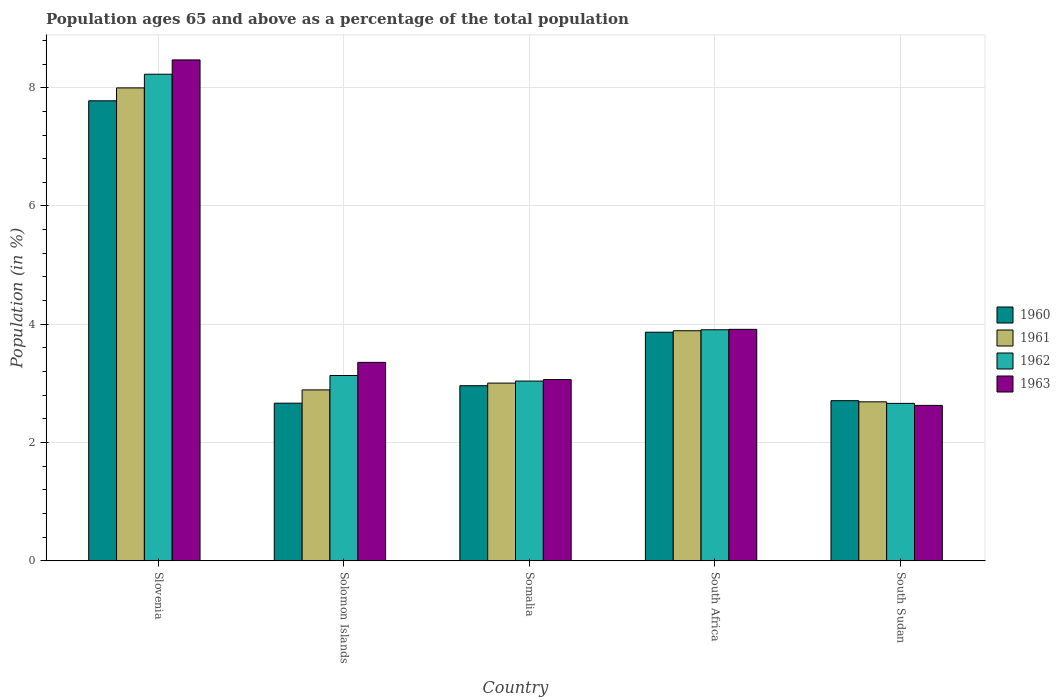How many different coloured bars are there?
Ensure brevity in your answer.  4. Are the number of bars per tick equal to the number of legend labels?
Ensure brevity in your answer.  Yes. What is the label of the 1st group of bars from the left?
Your answer should be compact. Slovenia. In how many cases, is the number of bars for a given country not equal to the number of legend labels?
Keep it short and to the point. 0. What is the percentage of the population ages 65 and above in 1961 in South Sudan?
Make the answer very short. 2.69. Across all countries, what is the maximum percentage of the population ages 65 and above in 1962?
Your answer should be very brief. 8.23. Across all countries, what is the minimum percentage of the population ages 65 and above in 1963?
Offer a terse response. 2.63. In which country was the percentage of the population ages 65 and above in 1961 maximum?
Make the answer very short. Slovenia. In which country was the percentage of the population ages 65 and above in 1962 minimum?
Keep it short and to the point. South Sudan. What is the total percentage of the population ages 65 and above in 1961 in the graph?
Your answer should be compact. 20.47. What is the difference between the percentage of the population ages 65 and above in 1962 in South Africa and that in South Sudan?
Offer a very short reply. 1.24. What is the difference between the percentage of the population ages 65 and above in 1960 in South Africa and the percentage of the population ages 65 and above in 1963 in Solomon Islands?
Keep it short and to the point. 0.51. What is the average percentage of the population ages 65 and above in 1962 per country?
Provide a succinct answer. 4.19. What is the difference between the percentage of the population ages 65 and above of/in 1960 and percentage of the population ages 65 and above of/in 1962 in South Sudan?
Your response must be concise. 0.05. What is the ratio of the percentage of the population ages 65 and above in 1960 in Slovenia to that in South Africa?
Provide a short and direct response. 2.01. What is the difference between the highest and the second highest percentage of the population ages 65 and above in 1962?
Your answer should be compact. 4.32. What is the difference between the highest and the lowest percentage of the population ages 65 and above in 1961?
Offer a very short reply. 5.31. In how many countries, is the percentage of the population ages 65 and above in 1963 greater than the average percentage of the population ages 65 and above in 1963 taken over all countries?
Your answer should be compact. 1. Is the sum of the percentage of the population ages 65 and above in 1962 in Solomon Islands and South Africa greater than the maximum percentage of the population ages 65 and above in 1963 across all countries?
Provide a succinct answer. No. Is it the case that in every country, the sum of the percentage of the population ages 65 and above in 1963 and percentage of the population ages 65 and above in 1960 is greater than the sum of percentage of the population ages 65 and above in 1961 and percentage of the population ages 65 and above in 1962?
Your response must be concise. No. What does the 2nd bar from the right in Slovenia represents?
Provide a succinct answer. 1962. Is it the case that in every country, the sum of the percentage of the population ages 65 and above in 1961 and percentage of the population ages 65 and above in 1962 is greater than the percentage of the population ages 65 and above in 1960?
Make the answer very short. Yes. How many bars are there?
Provide a short and direct response. 20. What is the difference between two consecutive major ticks on the Y-axis?
Ensure brevity in your answer.  2. Does the graph contain any zero values?
Make the answer very short. No. Does the graph contain grids?
Your answer should be compact. Yes. Where does the legend appear in the graph?
Ensure brevity in your answer.  Center right. How many legend labels are there?
Provide a succinct answer. 4. How are the legend labels stacked?
Offer a terse response. Vertical. What is the title of the graph?
Offer a terse response. Population ages 65 and above as a percentage of the total population. What is the label or title of the X-axis?
Give a very brief answer. Country. What is the label or title of the Y-axis?
Your answer should be very brief. Population (in %). What is the Population (in %) in 1960 in Slovenia?
Give a very brief answer. 7.78. What is the Population (in %) of 1961 in Slovenia?
Make the answer very short. 8. What is the Population (in %) of 1962 in Slovenia?
Your answer should be compact. 8.23. What is the Population (in %) in 1963 in Slovenia?
Offer a terse response. 8.47. What is the Population (in %) of 1960 in Solomon Islands?
Your answer should be very brief. 2.67. What is the Population (in %) in 1961 in Solomon Islands?
Provide a succinct answer. 2.89. What is the Population (in %) of 1962 in Solomon Islands?
Offer a very short reply. 3.13. What is the Population (in %) of 1963 in Solomon Islands?
Provide a short and direct response. 3.36. What is the Population (in %) of 1960 in Somalia?
Give a very brief answer. 2.96. What is the Population (in %) of 1961 in Somalia?
Ensure brevity in your answer.  3.01. What is the Population (in %) of 1962 in Somalia?
Provide a succinct answer. 3.04. What is the Population (in %) in 1963 in Somalia?
Offer a terse response. 3.06. What is the Population (in %) in 1960 in South Africa?
Your answer should be very brief. 3.87. What is the Population (in %) in 1961 in South Africa?
Provide a succinct answer. 3.89. What is the Population (in %) of 1962 in South Africa?
Your answer should be very brief. 3.91. What is the Population (in %) in 1963 in South Africa?
Your answer should be compact. 3.91. What is the Population (in %) in 1960 in South Sudan?
Provide a short and direct response. 2.71. What is the Population (in %) in 1961 in South Sudan?
Make the answer very short. 2.69. What is the Population (in %) of 1962 in South Sudan?
Ensure brevity in your answer.  2.66. What is the Population (in %) of 1963 in South Sudan?
Your answer should be very brief. 2.63. Across all countries, what is the maximum Population (in %) of 1960?
Your answer should be very brief. 7.78. Across all countries, what is the maximum Population (in %) in 1961?
Ensure brevity in your answer.  8. Across all countries, what is the maximum Population (in %) in 1962?
Your response must be concise. 8.23. Across all countries, what is the maximum Population (in %) of 1963?
Your response must be concise. 8.47. Across all countries, what is the minimum Population (in %) in 1960?
Make the answer very short. 2.67. Across all countries, what is the minimum Population (in %) of 1961?
Give a very brief answer. 2.69. Across all countries, what is the minimum Population (in %) of 1962?
Your response must be concise. 2.66. Across all countries, what is the minimum Population (in %) of 1963?
Offer a terse response. 2.63. What is the total Population (in %) of 1960 in the graph?
Provide a short and direct response. 19.98. What is the total Population (in %) in 1961 in the graph?
Your answer should be very brief. 20.47. What is the total Population (in %) of 1962 in the graph?
Ensure brevity in your answer.  20.97. What is the total Population (in %) in 1963 in the graph?
Provide a short and direct response. 21.43. What is the difference between the Population (in %) in 1960 in Slovenia and that in Solomon Islands?
Make the answer very short. 5.11. What is the difference between the Population (in %) in 1961 in Slovenia and that in Solomon Islands?
Your response must be concise. 5.11. What is the difference between the Population (in %) of 1962 in Slovenia and that in Solomon Islands?
Make the answer very short. 5.09. What is the difference between the Population (in %) in 1963 in Slovenia and that in Solomon Islands?
Offer a very short reply. 5.11. What is the difference between the Population (in %) of 1960 in Slovenia and that in Somalia?
Your response must be concise. 4.82. What is the difference between the Population (in %) of 1961 in Slovenia and that in Somalia?
Make the answer very short. 4.99. What is the difference between the Population (in %) of 1962 in Slovenia and that in Somalia?
Your answer should be very brief. 5.19. What is the difference between the Population (in %) of 1963 in Slovenia and that in Somalia?
Provide a short and direct response. 5.41. What is the difference between the Population (in %) in 1960 in Slovenia and that in South Africa?
Your response must be concise. 3.91. What is the difference between the Population (in %) of 1961 in Slovenia and that in South Africa?
Your answer should be compact. 4.11. What is the difference between the Population (in %) in 1962 in Slovenia and that in South Africa?
Give a very brief answer. 4.32. What is the difference between the Population (in %) of 1963 in Slovenia and that in South Africa?
Keep it short and to the point. 4.56. What is the difference between the Population (in %) in 1960 in Slovenia and that in South Sudan?
Ensure brevity in your answer.  5.07. What is the difference between the Population (in %) of 1961 in Slovenia and that in South Sudan?
Make the answer very short. 5.31. What is the difference between the Population (in %) in 1962 in Slovenia and that in South Sudan?
Offer a very short reply. 5.57. What is the difference between the Population (in %) in 1963 in Slovenia and that in South Sudan?
Provide a short and direct response. 5.84. What is the difference between the Population (in %) in 1960 in Solomon Islands and that in Somalia?
Offer a terse response. -0.3. What is the difference between the Population (in %) of 1961 in Solomon Islands and that in Somalia?
Your response must be concise. -0.11. What is the difference between the Population (in %) in 1962 in Solomon Islands and that in Somalia?
Keep it short and to the point. 0.09. What is the difference between the Population (in %) in 1963 in Solomon Islands and that in Somalia?
Your answer should be compact. 0.29. What is the difference between the Population (in %) of 1960 in Solomon Islands and that in South Africa?
Keep it short and to the point. -1.2. What is the difference between the Population (in %) of 1961 in Solomon Islands and that in South Africa?
Provide a succinct answer. -1. What is the difference between the Population (in %) of 1962 in Solomon Islands and that in South Africa?
Make the answer very short. -0.77. What is the difference between the Population (in %) in 1963 in Solomon Islands and that in South Africa?
Keep it short and to the point. -0.56. What is the difference between the Population (in %) of 1960 in Solomon Islands and that in South Sudan?
Offer a terse response. -0.04. What is the difference between the Population (in %) of 1961 in Solomon Islands and that in South Sudan?
Keep it short and to the point. 0.2. What is the difference between the Population (in %) in 1962 in Solomon Islands and that in South Sudan?
Provide a succinct answer. 0.47. What is the difference between the Population (in %) in 1963 in Solomon Islands and that in South Sudan?
Make the answer very short. 0.73. What is the difference between the Population (in %) of 1960 in Somalia and that in South Africa?
Your answer should be compact. -0.9. What is the difference between the Population (in %) of 1961 in Somalia and that in South Africa?
Offer a terse response. -0.89. What is the difference between the Population (in %) of 1962 in Somalia and that in South Africa?
Offer a terse response. -0.87. What is the difference between the Population (in %) of 1963 in Somalia and that in South Africa?
Ensure brevity in your answer.  -0.85. What is the difference between the Population (in %) of 1960 in Somalia and that in South Sudan?
Provide a short and direct response. 0.25. What is the difference between the Population (in %) of 1961 in Somalia and that in South Sudan?
Make the answer very short. 0.32. What is the difference between the Population (in %) of 1962 in Somalia and that in South Sudan?
Give a very brief answer. 0.38. What is the difference between the Population (in %) of 1963 in Somalia and that in South Sudan?
Give a very brief answer. 0.44. What is the difference between the Population (in %) in 1960 in South Africa and that in South Sudan?
Your answer should be very brief. 1.16. What is the difference between the Population (in %) in 1961 in South Africa and that in South Sudan?
Your answer should be very brief. 1.2. What is the difference between the Population (in %) in 1962 in South Africa and that in South Sudan?
Keep it short and to the point. 1.24. What is the difference between the Population (in %) of 1963 in South Africa and that in South Sudan?
Ensure brevity in your answer.  1.29. What is the difference between the Population (in %) in 1960 in Slovenia and the Population (in %) in 1961 in Solomon Islands?
Give a very brief answer. 4.89. What is the difference between the Population (in %) in 1960 in Slovenia and the Population (in %) in 1962 in Solomon Islands?
Offer a very short reply. 4.64. What is the difference between the Population (in %) of 1960 in Slovenia and the Population (in %) of 1963 in Solomon Islands?
Provide a short and direct response. 4.42. What is the difference between the Population (in %) of 1961 in Slovenia and the Population (in %) of 1962 in Solomon Islands?
Your response must be concise. 4.86. What is the difference between the Population (in %) in 1961 in Slovenia and the Population (in %) in 1963 in Solomon Islands?
Ensure brevity in your answer.  4.64. What is the difference between the Population (in %) of 1962 in Slovenia and the Population (in %) of 1963 in Solomon Islands?
Offer a terse response. 4.87. What is the difference between the Population (in %) of 1960 in Slovenia and the Population (in %) of 1961 in Somalia?
Offer a terse response. 4.77. What is the difference between the Population (in %) in 1960 in Slovenia and the Population (in %) in 1962 in Somalia?
Provide a short and direct response. 4.74. What is the difference between the Population (in %) in 1960 in Slovenia and the Population (in %) in 1963 in Somalia?
Provide a short and direct response. 4.71. What is the difference between the Population (in %) in 1961 in Slovenia and the Population (in %) in 1962 in Somalia?
Give a very brief answer. 4.96. What is the difference between the Population (in %) in 1961 in Slovenia and the Population (in %) in 1963 in Somalia?
Offer a terse response. 4.93. What is the difference between the Population (in %) of 1962 in Slovenia and the Population (in %) of 1963 in Somalia?
Provide a succinct answer. 5.16. What is the difference between the Population (in %) in 1960 in Slovenia and the Population (in %) in 1961 in South Africa?
Offer a terse response. 3.89. What is the difference between the Population (in %) in 1960 in Slovenia and the Population (in %) in 1962 in South Africa?
Make the answer very short. 3.87. What is the difference between the Population (in %) of 1960 in Slovenia and the Population (in %) of 1963 in South Africa?
Provide a succinct answer. 3.86. What is the difference between the Population (in %) in 1961 in Slovenia and the Population (in %) in 1962 in South Africa?
Provide a succinct answer. 4.09. What is the difference between the Population (in %) of 1961 in Slovenia and the Population (in %) of 1963 in South Africa?
Provide a succinct answer. 4.08. What is the difference between the Population (in %) in 1962 in Slovenia and the Population (in %) in 1963 in South Africa?
Offer a terse response. 4.31. What is the difference between the Population (in %) of 1960 in Slovenia and the Population (in %) of 1961 in South Sudan?
Provide a succinct answer. 5.09. What is the difference between the Population (in %) in 1960 in Slovenia and the Population (in %) in 1962 in South Sudan?
Ensure brevity in your answer.  5.12. What is the difference between the Population (in %) in 1960 in Slovenia and the Population (in %) in 1963 in South Sudan?
Keep it short and to the point. 5.15. What is the difference between the Population (in %) of 1961 in Slovenia and the Population (in %) of 1962 in South Sudan?
Offer a terse response. 5.33. What is the difference between the Population (in %) in 1961 in Slovenia and the Population (in %) in 1963 in South Sudan?
Offer a terse response. 5.37. What is the difference between the Population (in %) of 1962 in Slovenia and the Population (in %) of 1963 in South Sudan?
Make the answer very short. 5.6. What is the difference between the Population (in %) in 1960 in Solomon Islands and the Population (in %) in 1961 in Somalia?
Offer a terse response. -0.34. What is the difference between the Population (in %) of 1960 in Solomon Islands and the Population (in %) of 1962 in Somalia?
Give a very brief answer. -0.37. What is the difference between the Population (in %) in 1960 in Solomon Islands and the Population (in %) in 1963 in Somalia?
Offer a terse response. -0.4. What is the difference between the Population (in %) of 1961 in Solomon Islands and the Population (in %) of 1962 in Somalia?
Your response must be concise. -0.15. What is the difference between the Population (in %) in 1961 in Solomon Islands and the Population (in %) in 1963 in Somalia?
Ensure brevity in your answer.  -0.17. What is the difference between the Population (in %) of 1962 in Solomon Islands and the Population (in %) of 1963 in Somalia?
Offer a very short reply. 0.07. What is the difference between the Population (in %) of 1960 in Solomon Islands and the Population (in %) of 1961 in South Africa?
Your answer should be very brief. -1.22. What is the difference between the Population (in %) of 1960 in Solomon Islands and the Population (in %) of 1962 in South Africa?
Provide a succinct answer. -1.24. What is the difference between the Population (in %) in 1960 in Solomon Islands and the Population (in %) in 1963 in South Africa?
Offer a terse response. -1.25. What is the difference between the Population (in %) of 1961 in Solomon Islands and the Population (in %) of 1962 in South Africa?
Your answer should be very brief. -1.02. What is the difference between the Population (in %) in 1961 in Solomon Islands and the Population (in %) in 1963 in South Africa?
Provide a short and direct response. -1.02. What is the difference between the Population (in %) in 1962 in Solomon Islands and the Population (in %) in 1963 in South Africa?
Give a very brief answer. -0.78. What is the difference between the Population (in %) of 1960 in Solomon Islands and the Population (in %) of 1961 in South Sudan?
Offer a terse response. -0.02. What is the difference between the Population (in %) in 1960 in Solomon Islands and the Population (in %) in 1962 in South Sudan?
Offer a terse response. 0. What is the difference between the Population (in %) of 1960 in Solomon Islands and the Population (in %) of 1963 in South Sudan?
Offer a terse response. 0.04. What is the difference between the Population (in %) of 1961 in Solomon Islands and the Population (in %) of 1962 in South Sudan?
Offer a terse response. 0.23. What is the difference between the Population (in %) of 1961 in Solomon Islands and the Population (in %) of 1963 in South Sudan?
Your response must be concise. 0.26. What is the difference between the Population (in %) of 1962 in Solomon Islands and the Population (in %) of 1963 in South Sudan?
Give a very brief answer. 0.51. What is the difference between the Population (in %) in 1960 in Somalia and the Population (in %) in 1961 in South Africa?
Your answer should be very brief. -0.93. What is the difference between the Population (in %) in 1960 in Somalia and the Population (in %) in 1962 in South Africa?
Keep it short and to the point. -0.95. What is the difference between the Population (in %) of 1960 in Somalia and the Population (in %) of 1963 in South Africa?
Your answer should be compact. -0.95. What is the difference between the Population (in %) of 1961 in Somalia and the Population (in %) of 1962 in South Africa?
Make the answer very short. -0.9. What is the difference between the Population (in %) in 1961 in Somalia and the Population (in %) in 1963 in South Africa?
Your answer should be very brief. -0.91. What is the difference between the Population (in %) in 1962 in Somalia and the Population (in %) in 1963 in South Africa?
Ensure brevity in your answer.  -0.87. What is the difference between the Population (in %) in 1960 in Somalia and the Population (in %) in 1961 in South Sudan?
Provide a short and direct response. 0.27. What is the difference between the Population (in %) in 1960 in Somalia and the Population (in %) in 1962 in South Sudan?
Provide a short and direct response. 0.3. What is the difference between the Population (in %) of 1960 in Somalia and the Population (in %) of 1963 in South Sudan?
Make the answer very short. 0.33. What is the difference between the Population (in %) in 1961 in Somalia and the Population (in %) in 1962 in South Sudan?
Your answer should be very brief. 0.34. What is the difference between the Population (in %) of 1961 in Somalia and the Population (in %) of 1963 in South Sudan?
Your answer should be very brief. 0.38. What is the difference between the Population (in %) of 1962 in Somalia and the Population (in %) of 1963 in South Sudan?
Keep it short and to the point. 0.41. What is the difference between the Population (in %) in 1960 in South Africa and the Population (in %) in 1961 in South Sudan?
Your response must be concise. 1.18. What is the difference between the Population (in %) in 1960 in South Africa and the Population (in %) in 1962 in South Sudan?
Your response must be concise. 1.2. What is the difference between the Population (in %) of 1960 in South Africa and the Population (in %) of 1963 in South Sudan?
Offer a terse response. 1.24. What is the difference between the Population (in %) of 1961 in South Africa and the Population (in %) of 1962 in South Sudan?
Your response must be concise. 1.23. What is the difference between the Population (in %) in 1961 in South Africa and the Population (in %) in 1963 in South Sudan?
Your response must be concise. 1.26. What is the difference between the Population (in %) of 1962 in South Africa and the Population (in %) of 1963 in South Sudan?
Keep it short and to the point. 1.28. What is the average Population (in %) in 1960 per country?
Keep it short and to the point. 4. What is the average Population (in %) in 1961 per country?
Ensure brevity in your answer.  4.09. What is the average Population (in %) in 1962 per country?
Keep it short and to the point. 4.19. What is the average Population (in %) in 1963 per country?
Make the answer very short. 4.29. What is the difference between the Population (in %) of 1960 and Population (in %) of 1961 in Slovenia?
Your answer should be compact. -0.22. What is the difference between the Population (in %) of 1960 and Population (in %) of 1962 in Slovenia?
Give a very brief answer. -0.45. What is the difference between the Population (in %) of 1960 and Population (in %) of 1963 in Slovenia?
Offer a terse response. -0.69. What is the difference between the Population (in %) in 1961 and Population (in %) in 1962 in Slovenia?
Ensure brevity in your answer.  -0.23. What is the difference between the Population (in %) in 1961 and Population (in %) in 1963 in Slovenia?
Your answer should be compact. -0.47. What is the difference between the Population (in %) in 1962 and Population (in %) in 1963 in Slovenia?
Your response must be concise. -0.24. What is the difference between the Population (in %) of 1960 and Population (in %) of 1961 in Solomon Islands?
Ensure brevity in your answer.  -0.22. What is the difference between the Population (in %) of 1960 and Population (in %) of 1962 in Solomon Islands?
Provide a short and direct response. -0.47. What is the difference between the Population (in %) of 1960 and Population (in %) of 1963 in Solomon Islands?
Provide a short and direct response. -0.69. What is the difference between the Population (in %) of 1961 and Population (in %) of 1962 in Solomon Islands?
Provide a succinct answer. -0.24. What is the difference between the Population (in %) of 1961 and Population (in %) of 1963 in Solomon Islands?
Offer a terse response. -0.47. What is the difference between the Population (in %) in 1962 and Population (in %) in 1963 in Solomon Islands?
Your answer should be very brief. -0.22. What is the difference between the Population (in %) in 1960 and Population (in %) in 1961 in Somalia?
Your answer should be very brief. -0.04. What is the difference between the Population (in %) in 1960 and Population (in %) in 1962 in Somalia?
Provide a succinct answer. -0.08. What is the difference between the Population (in %) in 1960 and Population (in %) in 1963 in Somalia?
Offer a very short reply. -0.1. What is the difference between the Population (in %) in 1961 and Population (in %) in 1962 in Somalia?
Offer a very short reply. -0.03. What is the difference between the Population (in %) in 1961 and Population (in %) in 1963 in Somalia?
Offer a terse response. -0.06. What is the difference between the Population (in %) in 1962 and Population (in %) in 1963 in Somalia?
Offer a terse response. -0.02. What is the difference between the Population (in %) of 1960 and Population (in %) of 1961 in South Africa?
Offer a very short reply. -0.03. What is the difference between the Population (in %) of 1960 and Population (in %) of 1962 in South Africa?
Your answer should be very brief. -0.04. What is the difference between the Population (in %) of 1960 and Population (in %) of 1963 in South Africa?
Make the answer very short. -0.05. What is the difference between the Population (in %) of 1961 and Population (in %) of 1962 in South Africa?
Provide a short and direct response. -0.02. What is the difference between the Population (in %) of 1961 and Population (in %) of 1963 in South Africa?
Offer a very short reply. -0.02. What is the difference between the Population (in %) in 1962 and Population (in %) in 1963 in South Africa?
Your response must be concise. -0.01. What is the difference between the Population (in %) of 1960 and Population (in %) of 1961 in South Sudan?
Make the answer very short. 0.02. What is the difference between the Population (in %) in 1960 and Population (in %) in 1962 in South Sudan?
Your response must be concise. 0.05. What is the difference between the Population (in %) of 1960 and Population (in %) of 1963 in South Sudan?
Your answer should be compact. 0.08. What is the difference between the Population (in %) of 1961 and Population (in %) of 1962 in South Sudan?
Offer a very short reply. 0.03. What is the difference between the Population (in %) of 1961 and Population (in %) of 1963 in South Sudan?
Provide a succinct answer. 0.06. What is the difference between the Population (in %) in 1962 and Population (in %) in 1963 in South Sudan?
Make the answer very short. 0.03. What is the ratio of the Population (in %) in 1960 in Slovenia to that in Solomon Islands?
Your answer should be compact. 2.92. What is the ratio of the Population (in %) of 1961 in Slovenia to that in Solomon Islands?
Give a very brief answer. 2.77. What is the ratio of the Population (in %) of 1962 in Slovenia to that in Solomon Islands?
Your answer should be compact. 2.63. What is the ratio of the Population (in %) in 1963 in Slovenia to that in Solomon Islands?
Keep it short and to the point. 2.52. What is the ratio of the Population (in %) in 1960 in Slovenia to that in Somalia?
Offer a terse response. 2.63. What is the ratio of the Population (in %) of 1961 in Slovenia to that in Somalia?
Your response must be concise. 2.66. What is the ratio of the Population (in %) of 1962 in Slovenia to that in Somalia?
Provide a short and direct response. 2.71. What is the ratio of the Population (in %) of 1963 in Slovenia to that in Somalia?
Offer a very short reply. 2.76. What is the ratio of the Population (in %) in 1960 in Slovenia to that in South Africa?
Provide a short and direct response. 2.01. What is the ratio of the Population (in %) in 1961 in Slovenia to that in South Africa?
Ensure brevity in your answer.  2.06. What is the ratio of the Population (in %) in 1962 in Slovenia to that in South Africa?
Make the answer very short. 2.11. What is the ratio of the Population (in %) in 1963 in Slovenia to that in South Africa?
Provide a succinct answer. 2.16. What is the ratio of the Population (in %) of 1960 in Slovenia to that in South Sudan?
Ensure brevity in your answer.  2.87. What is the ratio of the Population (in %) in 1961 in Slovenia to that in South Sudan?
Offer a very short reply. 2.97. What is the ratio of the Population (in %) in 1962 in Slovenia to that in South Sudan?
Make the answer very short. 3.09. What is the ratio of the Population (in %) in 1963 in Slovenia to that in South Sudan?
Your response must be concise. 3.22. What is the ratio of the Population (in %) in 1960 in Solomon Islands to that in Somalia?
Keep it short and to the point. 0.9. What is the ratio of the Population (in %) of 1961 in Solomon Islands to that in Somalia?
Offer a terse response. 0.96. What is the ratio of the Population (in %) in 1962 in Solomon Islands to that in Somalia?
Ensure brevity in your answer.  1.03. What is the ratio of the Population (in %) of 1963 in Solomon Islands to that in Somalia?
Give a very brief answer. 1.1. What is the ratio of the Population (in %) in 1960 in Solomon Islands to that in South Africa?
Offer a terse response. 0.69. What is the ratio of the Population (in %) in 1961 in Solomon Islands to that in South Africa?
Keep it short and to the point. 0.74. What is the ratio of the Population (in %) in 1962 in Solomon Islands to that in South Africa?
Offer a terse response. 0.8. What is the ratio of the Population (in %) of 1963 in Solomon Islands to that in South Africa?
Your answer should be compact. 0.86. What is the ratio of the Population (in %) of 1960 in Solomon Islands to that in South Sudan?
Your answer should be compact. 0.98. What is the ratio of the Population (in %) in 1961 in Solomon Islands to that in South Sudan?
Make the answer very short. 1.08. What is the ratio of the Population (in %) of 1962 in Solomon Islands to that in South Sudan?
Offer a very short reply. 1.18. What is the ratio of the Population (in %) in 1963 in Solomon Islands to that in South Sudan?
Your answer should be very brief. 1.28. What is the ratio of the Population (in %) in 1960 in Somalia to that in South Africa?
Provide a short and direct response. 0.77. What is the ratio of the Population (in %) of 1961 in Somalia to that in South Africa?
Your answer should be compact. 0.77. What is the ratio of the Population (in %) in 1962 in Somalia to that in South Africa?
Offer a terse response. 0.78. What is the ratio of the Population (in %) of 1963 in Somalia to that in South Africa?
Your response must be concise. 0.78. What is the ratio of the Population (in %) in 1960 in Somalia to that in South Sudan?
Provide a succinct answer. 1.09. What is the ratio of the Population (in %) in 1961 in Somalia to that in South Sudan?
Provide a succinct answer. 1.12. What is the ratio of the Population (in %) of 1962 in Somalia to that in South Sudan?
Ensure brevity in your answer.  1.14. What is the ratio of the Population (in %) in 1963 in Somalia to that in South Sudan?
Offer a very short reply. 1.17. What is the ratio of the Population (in %) in 1960 in South Africa to that in South Sudan?
Ensure brevity in your answer.  1.43. What is the ratio of the Population (in %) of 1961 in South Africa to that in South Sudan?
Offer a terse response. 1.45. What is the ratio of the Population (in %) in 1962 in South Africa to that in South Sudan?
Keep it short and to the point. 1.47. What is the ratio of the Population (in %) in 1963 in South Africa to that in South Sudan?
Offer a very short reply. 1.49. What is the difference between the highest and the second highest Population (in %) in 1960?
Provide a short and direct response. 3.91. What is the difference between the highest and the second highest Population (in %) of 1961?
Your response must be concise. 4.11. What is the difference between the highest and the second highest Population (in %) of 1962?
Make the answer very short. 4.32. What is the difference between the highest and the second highest Population (in %) in 1963?
Your response must be concise. 4.56. What is the difference between the highest and the lowest Population (in %) in 1960?
Your response must be concise. 5.11. What is the difference between the highest and the lowest Population (in %) in 1961?
Provide a short and direct response. 5.31. What is the difference between the highest and the lowest Population (in %) in 1962?
Offer a very short reply. 5.57. What is the difference between the highest and the lowest Population (in %) in 1963?
Keep it short and to the point. 5.84. 